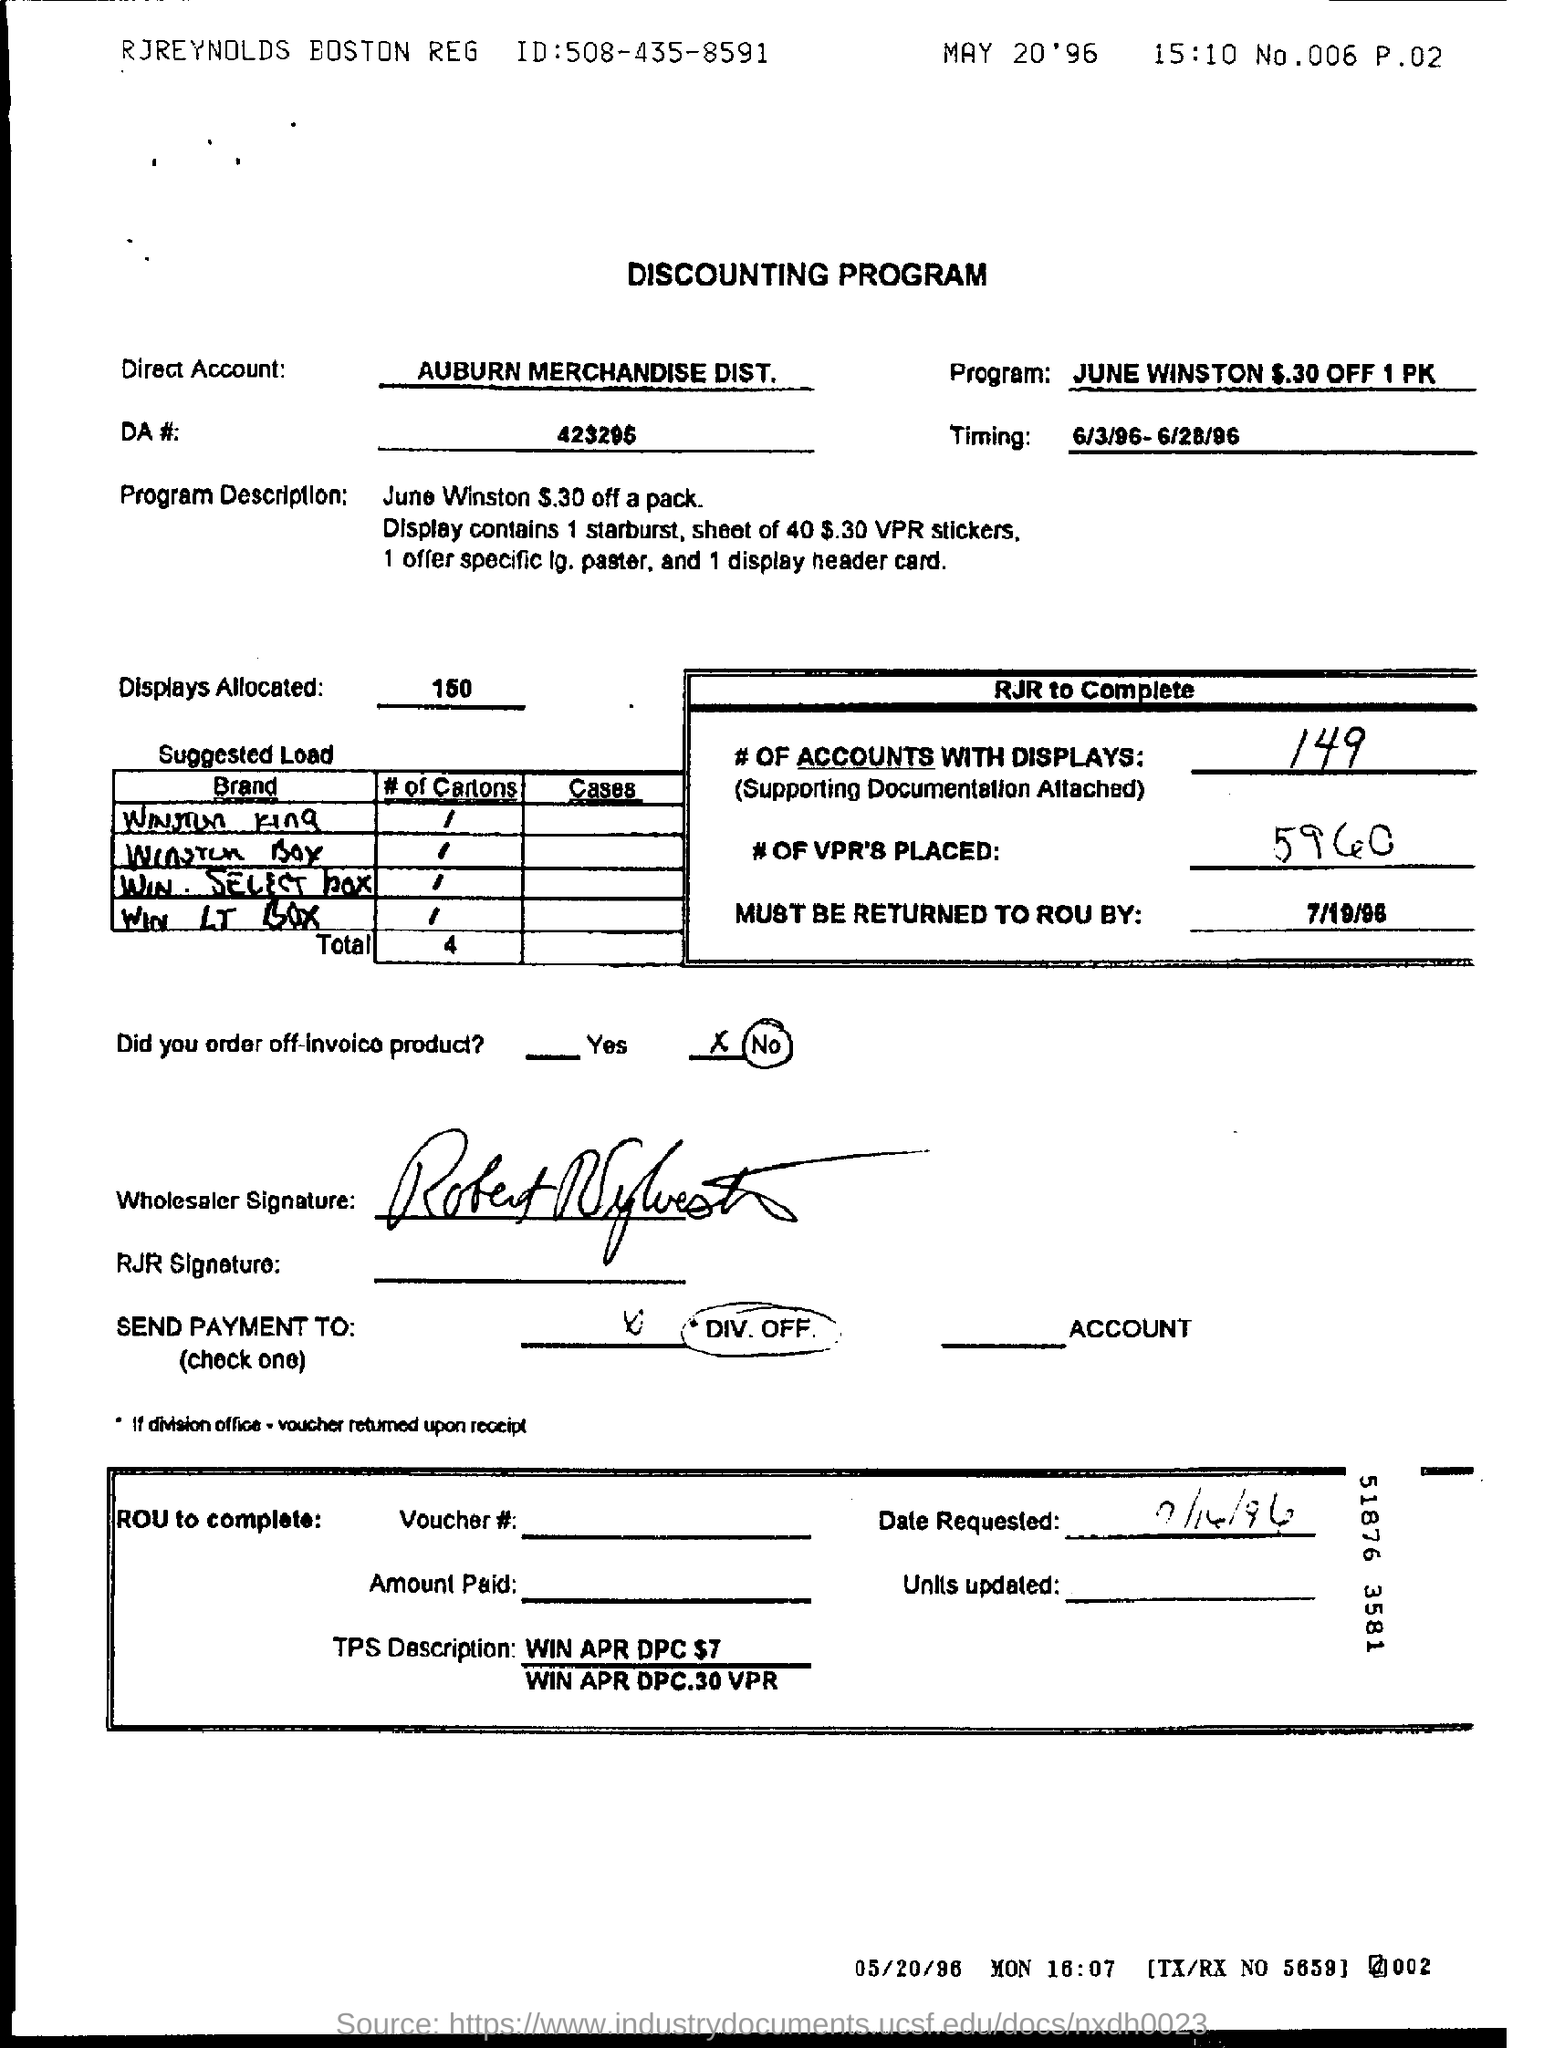Which  Direct Account is mentioned here?
Provide a short and direct response. Auburn merchandise dist. How many displays are being allocated?
Your answer should be very brief. 150. How many no of VPR's  are Placed?
Keep it short and to the point. 5960. What is the timing mentioned in the document?
Offer a very short reply. 6/3/96- 6/28/96. What is the no(#) of accounts with displays?
Provide a short and direct response. 149. What is the DA # (no)  given ?
Your answer should be very brief. 423295. 